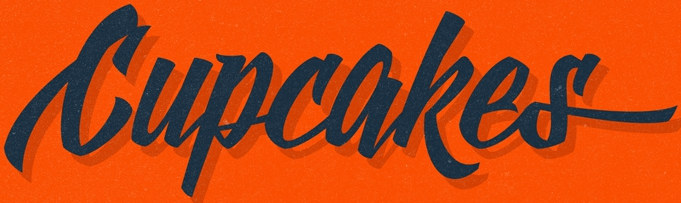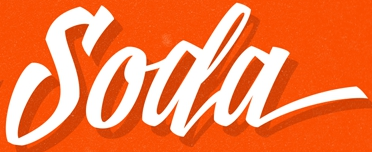Read the text from these images in sequence, separated by a semicolon. Cupcakes; Soda 